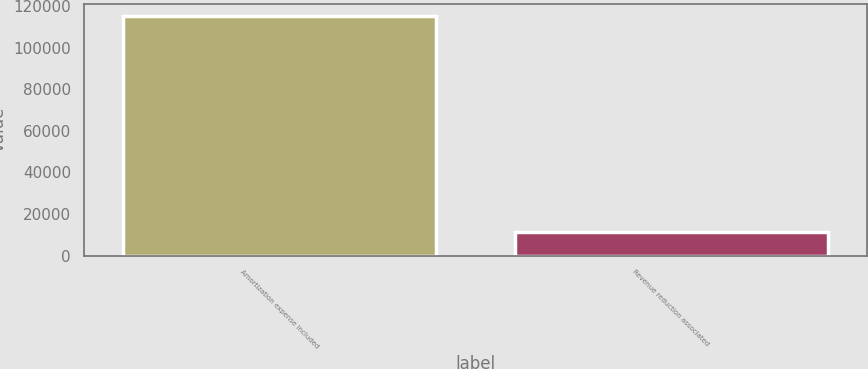<chart> <loc_0><loc_0><loc_500><loc_500><bar_chart><fcel>Amortization expense included<fcel>Revenue reduction associated<nl><fcel>115387<fcel>11253<nl></chart> 